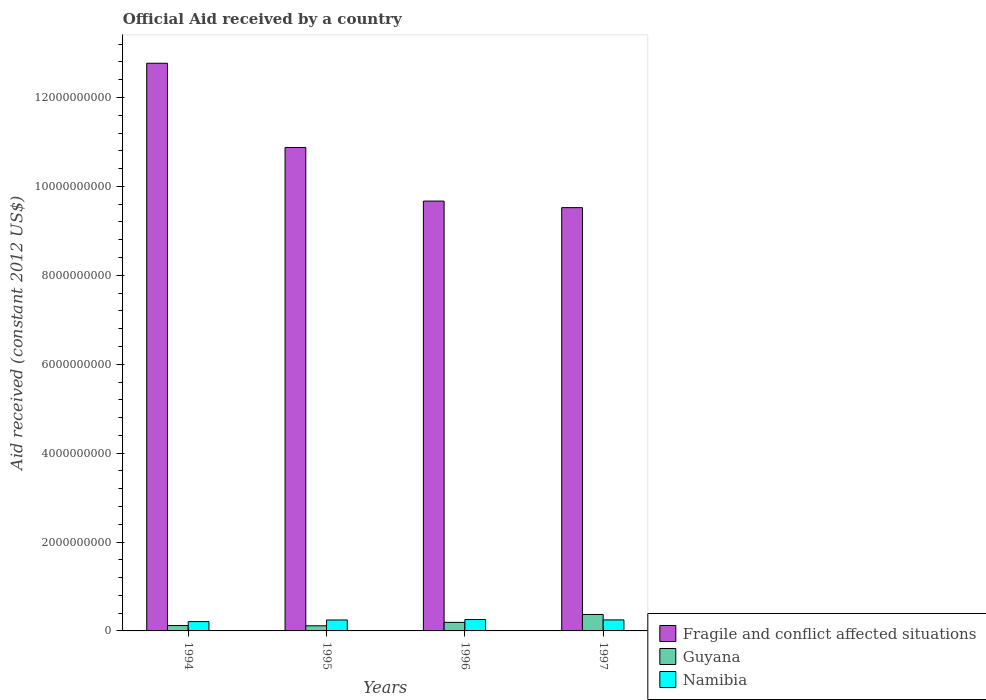Are the number of bars on each tick of the X-axis equal?
Your response must be concise. Yes. How many bars are there on the 1st tick from the left?
Make the answer very short. 3. In how many cases, is the number of bars for a given year not equal to the number of legend labels?
Provide a short and direct response. 0. What is the net official aid received in Guyana in 1995?
Your answer should be compact. 1.15e+08. Across all years, what is the maximum net official aid received in Namibia?
Give a very brief answer. 2.56e+08. Across all years, what is the minimum net official aid received in Namibia?
Your response must be concise. 2.10e+08. In which year was the net official aid received in Guyana minimum?
Offer a terse response. 1995. What is the total net official aid received in Guyana in the graph?
Offer a terse response. 7.99e+08. What is the difference between the net official aid received in Namibia in 1994 and that in 1995?
Offer a very short reply. -3.66e+07. What is the difference between the net official aid received in Fragile and conflict affected situations in 1994 and the net official aid received in Guyana in 1995?
Your answer should be very brief. 1.27e+1. What is the average net official aid received in Namibia per year?
Your answer should be very brief. 2.40e+08. In the year 1995, what is the difference between the net official aid received in Namibia and net official aid received in Fragile and conflict affected situations?
Offer a very short reply. -1.06e+1. In how many years, is the net official aid received in Guyana greater than 1200000000 US$?
Offer a terse response. 0. What is the ratio of the net official aid received in Namibia in 1996 to that in 1997?
Your response must be concise. 1.03. What is the difference between the highest and the second highest net official aid received in Namibia?
Keep it short and to the point. 8.59e+06. What is the difference between the highest and the lowest net official aid received in Guyana?
Your response must be concise. 2.55e+08. In how many years, is the net official aid received in Guyana greater than the average net official aid received in Guyana taken over all years?
Your response must be concise. 1. What does the 2nd bar from the left in 1996 represents?
Your answer should be very brief. Guyana. What does the 2nd bar from the right in 1996 represents?
Provide a short and direct response. Guyana. How many bars are there?
Offer a very short reply. 12. Are all the bars in the graph horizontal?
Make the answer very short. No. How many years are there in the graph?
Ensure brevity in your answer.  4. What is the difference between two consecutive major ticks on the Y-axis?
Give a very brief answer. 2.00e+09. Does the graph contain grids?
Make the answer very short. No. Where does the legend appear in the graph?
Make the answer very short. Bottom right. How many legend labels are there?
Give a very brief answer. 3. What is the title of the graph?
Give a very brief answer. Official Aid received by a country. Does "Isle of Man" appear as one of the legend labels in the graph?
Make the answer very short. No. What is the label or title of the Y-axis?
Ensure brevity in your answer.  Aid received (constant 2012 US$). What is the Aid received (constant 2012 US$) in Fragile and conflict affected situations in 1994?
Provide a short and direct response. 1.28e+1. What is the Aid received (constant 2012 US$) in Guyana in 1994?
Give a very brief answer. 1.21e+08. What is the Aid received (constant 2012 US$) in Namibia in 1994?
Provide a short and direct response. 2.10e+08. What is the Aid received (constant 2012 US$) in Fragile and conflict affected situations in 1995?
Provide a succinct answer. 1.09e+1. What is the Aid received (constant 2012 US$) of Guyana in 1995?
Your response must be concise. 1.15e+08. What is the Aid received (constant 2012 US$) in Namibia in 1995?
Make the answer very short. 2.46e+08. What is the Aid received (constant 2012 US$) of Fragile and conflict affected situations in 1996?
Offer a terse response. 9.67e+09. What is the Aid received (constant 2012 US$) in Guyana in 1996?
Offer a terse response. 1.92e+08. What is the Aid received (constant 2012 US$) of Namibia in 1996?
Provide a succinct answer. 2.56e+08. What is the Aid received (constant 2012 US$) of Fragile and conflict affected situations in 1997?
Your response must be concise. 9.52e+09. What is the Aid received (constant 2012 US$) of Guyana in 1997?
Provide a succinct answer. 3.70e+08. What is the Aid received (constant 2012 US$) of Namibia in 1997?
Give a very brief answer. 2.48e+08. Across all years, what is the maximum Aid received (constant 2012 US$) in Fragile and conflict affected situations?
Offer a terse response. 1.28e+1. Across all years, what is the maximum Aid received (constant 2012 US$) in Guyana?
Ensure brevity in your answer.  3.70e+08. Across all years, what is the maximum Aid received (constant 2012 US$) of Namibia?
Make the answer very short. 2.56e+08. Across all years, what is the minimum Aid received (constant 2012 US$) of Fragile and conflict affected situations?
Give a very brief answer. 9.52e+09. Across all years, what is the minimum Aid received (constant 2012 US$) in Guyana?
Your answer should be very brief. 1.15e+08. Across all years, what is the minimum Aid received (constant 2012 US$) of Namibia?
Provide a short and direct response. 2.10e+08. What is the total Aid received (constant 2012 US$) of Fragile and conflict affected situations in the graph?
Give a very brief answer. 4.28e+1. What is the total Aid received (constant 2012 US$) in Guyana in the graph?
Offer a very short reply. 7.99e+08. What is the total Aid received (constant 2012 US$) of Namibia in the graph?
Ensure brevity in your answer.  9.60e+08. What is the difference between the Aid received (constant 2012 US$) of Fragile and conflict affected situations in 1994 and that in 1995?
Give a very brief answer. 1.89e+09. What is the difference between the Aid received (constant 2012 US$) in Guyana in 1994 and that in 1995?
Your answer should be compact. 5.39e+06. What is the difference between the Aid received (constant 2012 US$) of Namibia in 1994 and that in 1995?
Ensure brevity in your answer.  -3.66e+07. What is the difference between the Aid received (constant 2012 US$) in Fragile and conflict affected situations in 1994 and that in 1996?
Offer a terse response. 3.10e+09. What is the difference between the Aid received (constant 2012 US$) of Guyana in 1994 and that in 1996?
Provide a succinct answer. -7.16e+07. What is the difference between the Aid received (constant 2012 US$) in Namibia in 1994 and that in 1996?
Your answer should be very brief. -4.66e+07. What is the difference between the Aid received (constant 2012 US$) of Fragile and conflict affected situations in 1994 and that in 1997?
Give a very brief answer. 3.25e+09. What is the difference between the Aid received (constant 2012 US$) of Guyana in 1994 and that in 1997?
Provide a succinct answer. -2.49e+08. What is the difference between the Aid received (constant 2012 US$) in Namibia in 1994 and that in 1997?
Provide a succinct answer. -3.80e+07. What is the difference between the Aid received (constant 2012 US$) of Fragile and conflict affected situations in 1995 and that in 1996?
Offer a terse response. 1.21e+09. What is the difference between the Aid received (constant 2012 US$) of Guyana in 1995 and that in 1996?
Make the answer very short. -7.70e+07. What is the difference between the Aid received (constant 2012 US$) in Namibia in 1995 and that in 1996?
Your response must be concise. -9.92e+06. What is the difference between the Aid received (constant 2012 US$) of Fragile and conflict affected situations in 1995 and that in 1997?
Your answer should be very brief. 1.35e+09. What is the difference between the Aid received (constant 2012 US$) in Guyana in 1995 and that in 1997?
Provide a succinct answer. -2.55e+08. What is the difference between the Aid received (constant 2012 US$) of Namibia in 1995 and that in 1997?
Provide a short and direct response. -1.33e+06. What is the difference between the Aid received (constant 2012 US$) of Fragile and conflict affected situations in 1996 and that in 1997?
Make the answer very short. 1.47e+08. What is the difference between the Aid received (constant 2012 US$) of Guyana in 1996 and that in 1997?
Give a very brief answer. -1.78e+08. What is the difference between the Aid received (constant 2012 US$) in Namibia in 1996 and that in 1997?
Ensure brevity in your answer.  8.59e+06. What is the difference between the Aid received (constant 2012 US$) of Fragile and conflict affected situations in 1994 and the Aid received (constant 2012 US$) of Guyana in 1995?
Your response must be concise. 1.27e+1. What is the difference between the Aid received (constant 2012 US$) of Fragile and conflict affected situations in 1994 and the Aid received (constant 2012 US$) of Namibia in 1995?
Make the answer very short. 1.25e+1. What is the difference between the Aid received (constant 2012 US$) of Guyana in 1994 and the Aid received (constant 2012 US$) of Namibia in 1995?
Make the answer very short. -1.26e+08. What is the difference between the Aid received (constant 2012 US$) in Fragile and conflict affected situations in 1994 and the Aid received (constant 2012 US$) in Guyana in 1996?
Your answer should be compact. 1.26e+1. What is the difference between the Aid received (constant 2012 US$) of Fragile and conflict affected situations in 1994 and the Aid received (constant 2012 US$) of Namibia in 1996?
Offer a very short reply. 1.25e+1. What is the difference between the Aid received (constant 2012 US$) of Guyana in 1994 and the Aid received (constant 2012 US$) of Namibia in 1996?
Your response must be concise. -1.35e+08. What is the difference between the Aid received (constant 2012 US$) of Fragile and conflict affected situations in 1994 and the Aid received (constant 2012 US$) of Guyana in 1997?
Your response must be concise. 1.24e+1. What is the difference between the Aid received (constant 2012 US$) in Fragile and conflict affected situations in 1994 and the Aid received (constant 2012 US$) in Namibia in 1997?
Provide a succinct answer. 1.25e+1. What is the difference between the Aid received (constant 2012 US$) in Guyana in 1994 and the Aid received (constant 2012 US$) in Namibia in 1997?
Give a very brief answer. -1.27e+08. What is the difference between the Aid received (constant 2012 US$) of Fragile and conflict affected situations in 1995 and the Aid received (constant 2012 US$) of Guyana in 1996?
Offer a terse response. 1.07e+1. What is the difference between the Aid received (constant 2012 US$) of Fragile and conflict affected situations in 1995 and the Aid received (constant 2012 US$) of Namibia in 1996?
Provide a short and direct response. 1.06e+1. What is the difference between the Aid received (constant 2012 US$) in Guyana in 1995 and the Aid received (constant 2012 US$) in Namibia in 1996?
Provide a short and direct response. -1.41e+08. What is the difference between the Aid received (constant 2012 US$) of Fragile and conflict affected situations in 1995 and the Aid received (constant 2012 US$) of Guyana in 1997?
Provide a succinct answer. 1.05e+1. What is the difference between the Aid received (constant 2012 US$) of Fragile and conflict affected situations in 1995 and the Aid received (constant 2012 US$) of Namibia in 1997?
Provide a succinct answer. 1.06e+1. What is the difference between the Aid received (constant 2012 US$) in Guyana in 1995 and the Aid received (constant 2012 US$) in Namibia in 1997?
Offer a very short reply. -1.32e+08. What is the difference between the Aid received (constant 2012 US$) of Fragile and conflict affected situations in 1996 and the Aid received (constant 2012 US$) of Guyana in 1997?
Ensure brevity in your answer.  9.30e+09. What is the difference between the Aid received (constant 2012 US$) of Fragile and conflict affected situations in 1996 and the Aid received (constant 2012 US$) of Namibia in 1997?
Offer a very short reply. 9.42e+09. What is the difference between the Aid received (constant 2012 US$) of Guyana in 1996 and the Aid received (constant 2012 US$) of Namibia in 1997?
Offer a terse response. -5.53e+07. What is the average Aid received (constant 2012 US$) in Fragile and conflict affected situations per year?
Give a very brief answer. 1.07e+1. What is the average Aid received (constant 2012 US$) in Guyana per year?
Ensure brevity in your answer.  2.00e+08. What is the average Aid received (constant 2012 US$) in Namibia per year?
Ensure brevity in your answer.  2.40e+08. In the year 1994, what is the difference between the Aid received (constant 2012 US$) of Fragile and conflict affected situations and Aid received (constant 2012 US$) of Guyana?
Ensure brevity in your answer.  1.27e+1. In the year 1994, what is the difference between the Aid received (constant 2012 US$) in Fragile and conflict affected situations and Aid received (constant 2012 US$) in Namibia?
Provide a short and direct response. 1.26e+1. In the year 1994, what is the difference between the Aid received (constant 2012 US$) of Guyana and Aid received (constant 2012 US$) of Namibia?
Provide a succinct answer. -8.89e+07. In the year 1995, what is the difference between the Aid received (constant 2012 US$) of Fragile and conflict affected situations and Aid received (constant 2012 US$) of Guyana?
Your answer should be very brief. 1.08e+1. In the year 1995, what is the difference between the Aid received (constant 2012 US$) of Fragile and conflict affected situations and Aid received (constant 2012 US$) of Namibia?
Your answer should be compact. 1.06e+1. In the year 1995, what is the difference between the Aid received (constant 2012 US$) in Guyana and Aid received (constant 2012 US$) in Namibia?
Make the answer very short. -1.31e+08. In the year 1996, what is the difference between the Aid received (constant 2012 US$) in Fragile and conflict affected situations and Aid received (constant 2012 US$) in Guyana?
Offer a terse response. 9.48e+09. In the year 1996, what is the difference between the Aid received (constant 2012 US$) in Fragile and conflict affected situations and Aid received (constant 2012 US$) in Namibia?
Your answer should be compact. 9.41e+09. In the year 1996, what is the difference between the Aid received (constant 2012 US$) in Guyana and Aid received (constant 2012 US$) in Namibia?
Ensure brevity in your answer.  -6.39e+07. In the year 1997, what is the difference between the Aid received (constant 2012 US$) in Fragile and conflict affected situations and Aid received (constant 2012 US$) in Guyana?
Give a very brief answer. 9.15e+09. In the year 1997, what is the difference between the Aid received (constant 2012 US$) in Fragile and conflict affected situations and Aid received (constant 2012 US$) in Namibia?
Provide a succinct answer. 9.28e+09. In the year 1997, what is the difference between the Aid received (constant 2012 US$) of Guyana and Aid received (constant 2012 US$) of Namibia?
Give a very brief answer. 1.23e+08. What is the ratio of the Aid received (constant 2012 US$) of Fragile and conflict affected situations in 1994 to that in 1995?
Provide a short and direct response. 1.17. What is the ratio of the Aid received (constant 2012 US$) in Guyana in 1994 to that in 1995?
Your response must be concise. 1.05. What is the ratio of the Aid received (constant 2012 US$) in Namibia in 1994 to that in 1995?
Offer a very short reply. 0.85. What is the ratio of the Aid received (constant 2012 US$) of Fragile and conflict affected situations in 1994 to that in 1996?
Your answer should be very brief. 1.32. What is the ratio of the Aid received (constant 2012 US$) of Guyana in 1994 to that in 1996?
Your answer should be very brief. 0.63. What is the ratio of the Aid received (constant 2012 US$) of Namibia in 1994 to that in 1996?
Your answer should be very brief. 0.82. What is the ratio of the Aid received (constant 2012 US$) of Fragile and conflict affected situations in 1994 to that in 1997?
Your answer should be compact. 1.34. What is the ratio of the Aid received (constant 2012 US$) in Guyana in 1994 to that in 1997?
Keep it short and to the point. 0.33. What is the ratio of the Aid received (constant 2012 US$) of Namibia in 1994 to that in 1997?
Your response must be concise. 0.85. What is the ratio of the Aid received (constant 2012 US$) in Fragile and conflict affected situations in 1995 to that in 1996?
Provide a succinct answer. 1.12. What is the ratio of the Aid received (constant 2012 US$) in Guyana in 1995 to that in 1996?
Provide a succinct answer. 0.6. What is the ratio of the Aid received (constant 2012 US$) in Namibia in 1995 to that in 1996?
Your answer should be compact. 0.96. What is the ratio of the Aid received (constant 2012 US$) in Fragile and conflict affected situations in 1995 to that in 1997?
Ensure brevity in your answer.  1.14. What is the ratio of the Aid received (constant 2012 US$) in Guyana in 1995 to that in 1997?
Your answer should be compact. 0.31. What is the ratio of the Aid received (constant 2012 US$) in Namibia in 1995 to that in 1997?
Offer a terse response. 0.99. What is the ratio of the Aid received (constant 2012 US$) of Fragile and conflict affected situations in 1996 to that in 1997?
Provide a succinct answer. 1.02. What is the ratio of the Aid received (constant 2012 US$) in Guyana in 1996 to that in 1997?
Make the answer very short. 0.52. What is the ratio of the Aid received (constant 2012 US$) of Namibia in 1996 to that in 1997?
Ensure brevity in your answer.  1.03. What is the difference between the highest and the second highest Aid received (constant 2012 US$) of Fragile and conflict affected situations?
Give a very brief answer. 1.89e+09. What is the difference between the highest and the second highest Aid received (constant 2012 US$) of Guyana?
Ensure brevity in your answer.  1.78e+08. What is the difference between the highest and the second highest Aid received (constant 2012 US$) in Namibia?
Keep it short and to the point. 8.59e+06. What is the difference between the highest and the lowest Aid received (constant 2012 US$) of Fragile and conflict affected situations?
Give a very brief answer. 3.25e+09. What is the difference between the highest and the lowest Aid received (constant 2012 US$) of Guyana?
Keep it short and to the point. 2.55e+08. What is the difference between the highest and the lowest Aid received (constant 2012 US$) in Namibia?
Offer a very short reply. 4.66e+07. 